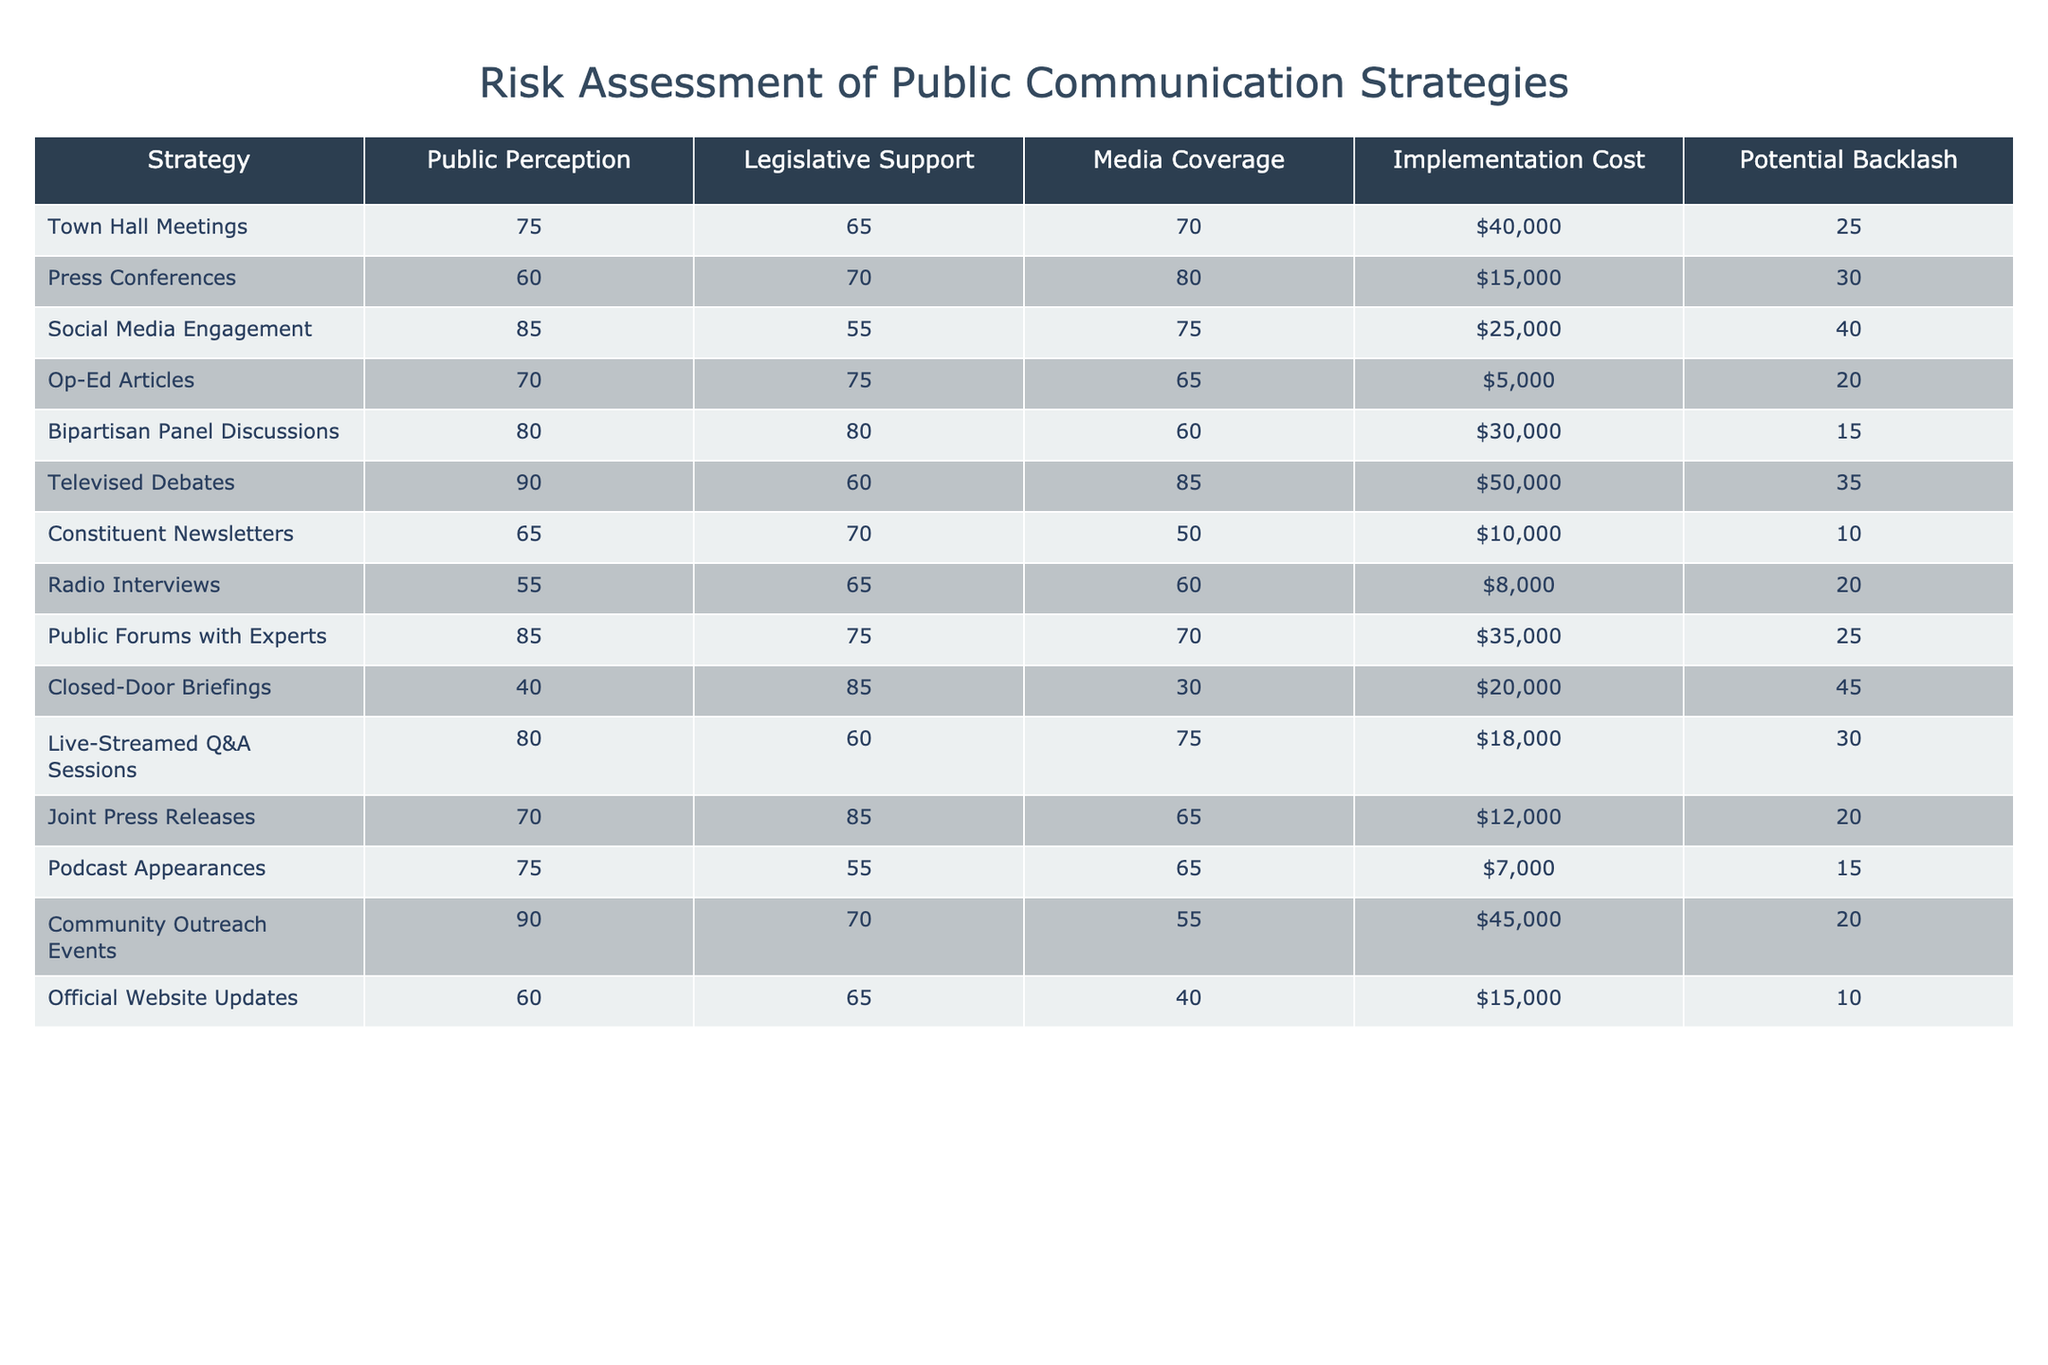What is the implementation cost of the "Televised Debates" strategy? The implementation cost for "Televised Debates" is directly listed in the table under the Implementation Cost column. It shows a value of 50000.
Answer: 50000 Which strategy has the highest public perception score? Looking through the Public Perception column, "Televised Debates" has the highest score of 90 compared to other strategies.
Answer: 90 Is "Closed-Door Briefings" supported by more legislators than "Press Conferences"? The Legislative Support score for "Closed-Door Briefings" is 85, while for "Press Conferences," it is 70. Therefore, "Closed-Door Briefings" has more legislative support.
Answer: Yes What is the average potential backlash for all strategies listed? To calculate the average potential backlash, add all the values in the Potential Backlash column: (25 + 30 + 40 + 20 + 15 + 35 + 10 + 20 + 25 + 45 + 30 + 20 + 15 + 20) =  390. Since there are 14 strategies, the average is 390 / 14 = 27.857.
Answer: 27.857 Which strategy offers the least media coverage, and what is its score? By reviewing the Media Coverage column, "Constituent Newsletters" has the lowest score of 50.
Answer: Constituent Newsletters, 50 Are there any strategies with a legislative support score of 80 or above? Checking the Legislative Support column, "Bipartisan Panel Discussions" (80), "Closed-Door Briefings" (85), and "Joint Press Releases" (85) all have scores of 80 or above.
Answer: Yes What is the difference in public perception between "Social Media Engagement" and "Op-Ed Articles"? The public perception score for "Social Media Engagement" is 85, while for "Op-Ed Articles" it is 70. The difference is 85 - 70 = 15.
Answer: 15 Which strategy has the lowest implementation cost and what is it? Through the Implementation Cost column, "Op-Ed Articles" shows the lowest cost of 5000 compared to the other strategies.
Answer: 5000 